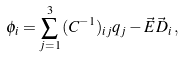<formula> <loc_0><loc_0><loc_500><loc_500>\phi _ { i } = \sum _ { j = 1 } ^ { 3 } \, ( C ^ { - 1 } ) _ { i j } q _ { j } - { \vec { E } } { \vec { D } } _ { i } \, ,</formula> 